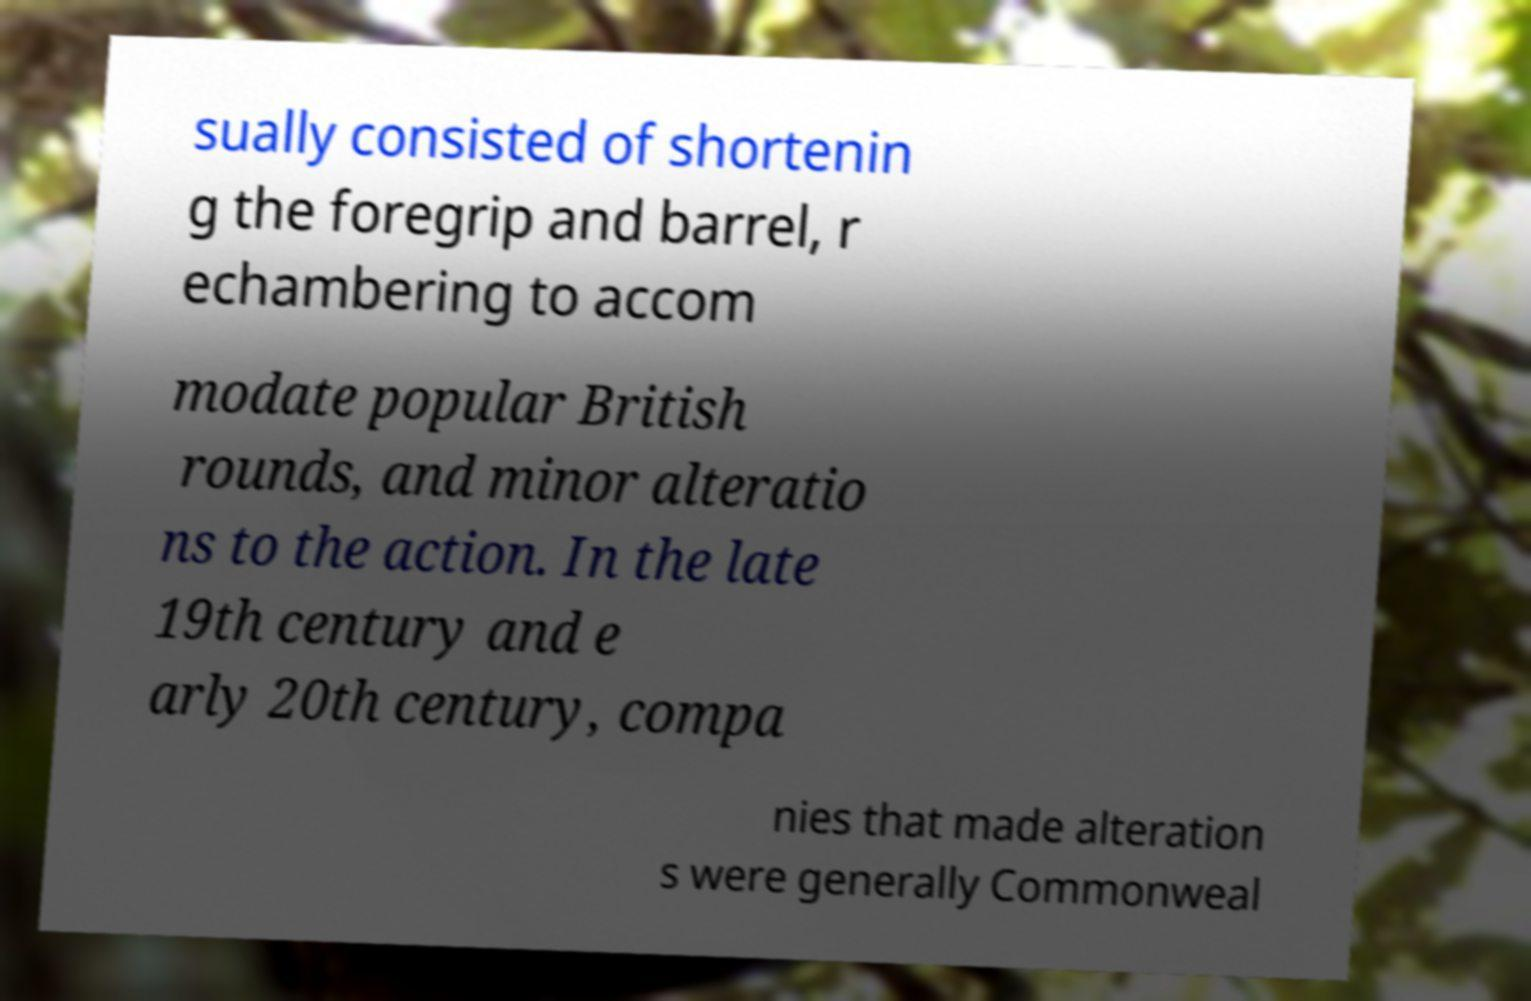There's text embedded in this image that I need extracted. Can you transcribe it verbatim? sually consisted of shortenin g the foregrip and barrel, r echambering to accom modate popular British rounds, and minor alteratio ns to the action. In the late 19th century and e arly 20th century, compa nies that made alteration s were generally Commonweal 